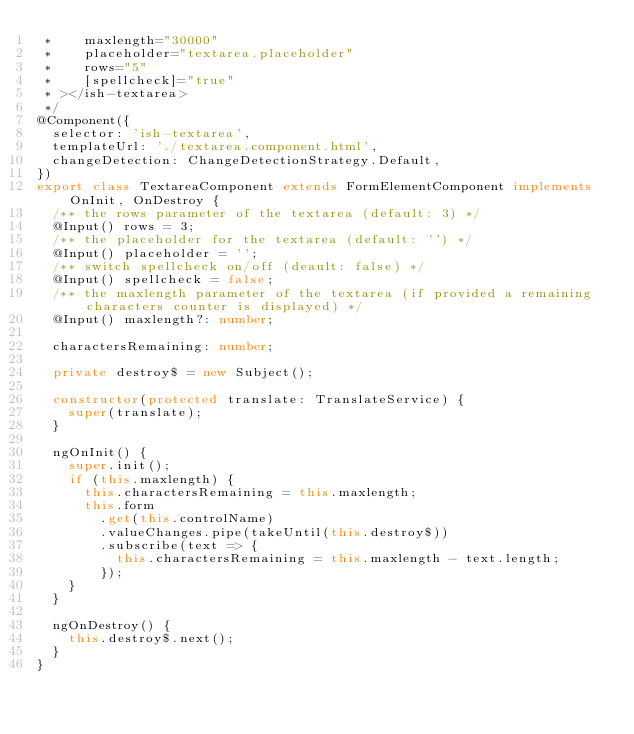Convert code to text. <code><loc_0><loc_0><loc_500><loc_500><_TypeScript_> *    maxlength="30000"
 *    placeholder="textarea.placeholder"
 *    rows="5"
 *    [spellcheck]="true"
 * ></ish-textarea>
 */
@Component({
  selector: 'ish-textarea',
  templateUrl: './textarea.component.html',
  changeDetection: ChangeDetectionStrategy.Default,
})
export class TextareaComponent extends FormElementComponent implements OnInit, OnDestroy {
  /** the rows parameter of the textarea (default: 3) */
  @Input() rows = 3;
  /** the placeholder for the textarea (default: '') */
  @Input() placeholder = '';
  /** switch spellcheck on/off (deault: false) */
  @Input() spellcheck = false;
  /** the maxlength parameter of the textarea (if provided a remaining characters counter is displayed) */
  @Input() maxlength?: number;

  charactersRemaining: number;

  private destroy$ = new Subject();

  constructor(protected translate: TranslateService) {
    super(translate);
  }

  ngOnInit() {
    super.init();
    if (this.maxlength) {
      this.charactersRemaining = this.maxlength;
      this.form
        .get(this.controlName)
        .valueChanges.pipe(takeUntil(this.destroy$))
        .subscribe(text => {
          this.charactersRemaining = this.maxlength - text.length;
        });
    }
  }

  ngOnDestroy() {
    this.destroy$.next();
  }
}
</code> 